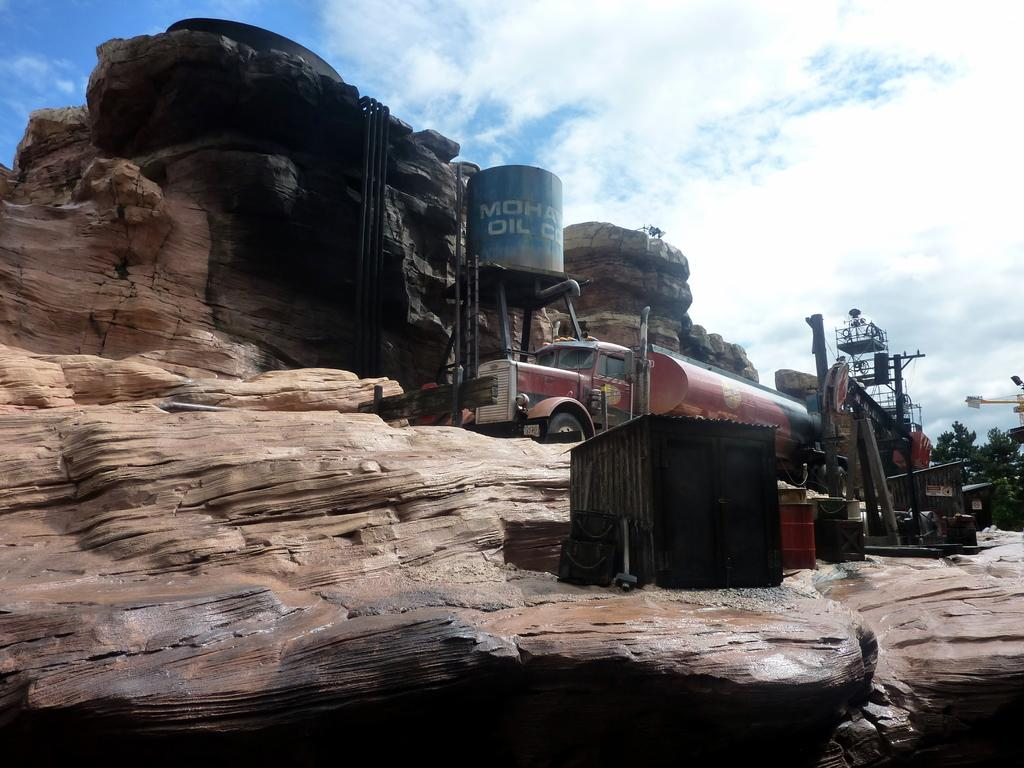What is the main subject of the image? There is a vehicle on a rock in the image. What other objects can be seen in the image? There are pipes, a tank, drums, a shed, and a crane in the image. Additionally, there are trees and a few unspecified objects. What is the weather like in the image? The sky is visible in the background of the image, and it appears to be cloudy. What type of house can be seen in the image? There is no house present in the image. How many shades of green can be seen on the edge of the rock? The image does not specify any shades of green, nor does it mention an edge of the rock. 